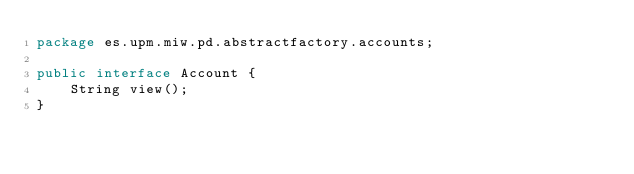Convert code to text. <code><loc_0><loc_0><loc_500><loc_500><_Java_>package es.upm.miw.pd.abstractfactory.accounts;

public interface Account {
    String view();
}
</code> 